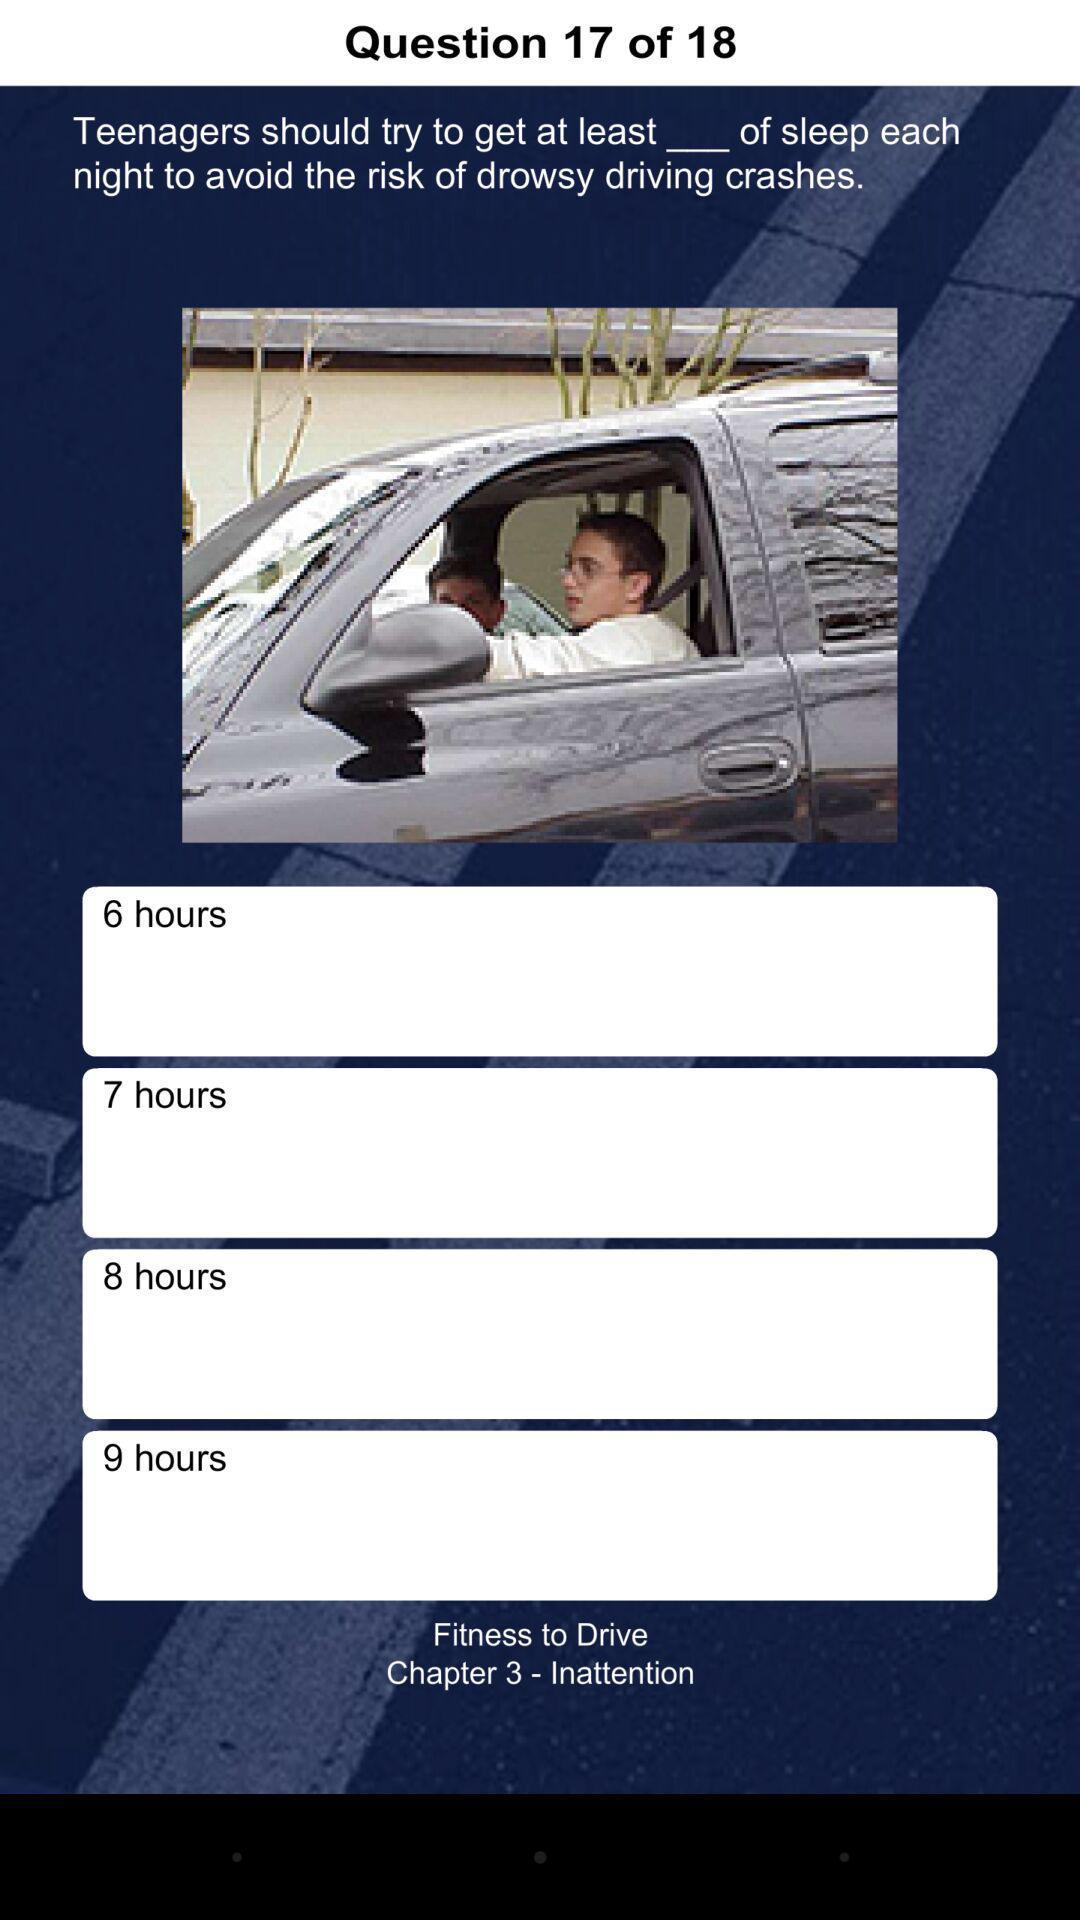How many hours of sleep is the minimum amount of sleep a teenager should get?
Answer the question using a single word or phrase. 6 hours 